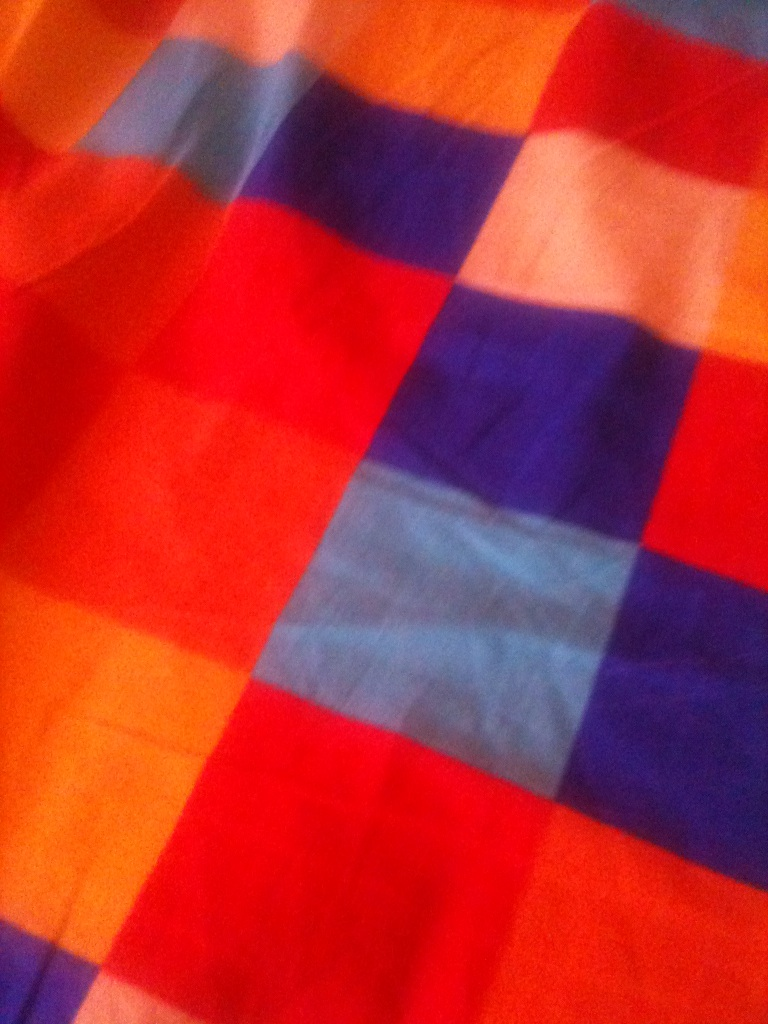This image evokes a nostalgic feeling. Can you tell me a story about it? Once upon a time, there was a small village known for its beautiful, handwoven fabrics. Each piece told a story and brought joy to everyone who saw it. This particular fabric was woven by an elderly woman named Grandmother Lila, who spent her evenings crafting intricate patterns while telling stories to her grandchildren. The vibrant colors represented the seasons in their village: the deep blues of the winter sky, the warm reds and oranges of autumn leaves, and the soft pinks of spring blossoms. As years passed, Grandmother Lila's fabric became a cherished family heirloom, reminding her descendants of the love, warmth, and traditions that bound their family together. 